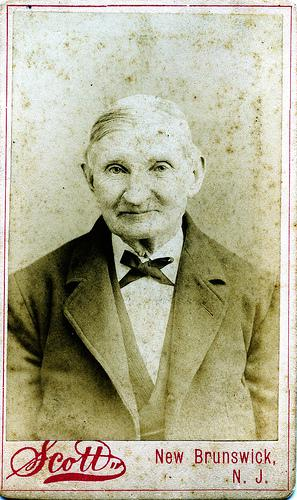Question: where was this picture taken?
Choices:
A. Las Vegas, NV.
B. New Brunswick, NJ.
C. Houston,TX.
D. Atlanta, GA.
Answer with the letter. Answer: B Question: where is the tie?
Choices:
A. In the closet.
B. Around the man's neck.
C. In the dresser drawer.
D. In the man's pocket.
Answer with the letter. Answer: B Question: what name is on the picture?
Choices:
A. Fred.
B. Jeff.
C. Scott.
D. Pete.
Answer with the letter. Answer: C Question: what color are the letters?
Choices:
A. Black.
B. Red.
C. White.
D. Green.
Answer with the letter. Answer: B Question: what kind of photo is this?
Choices:
A. Black and white.
B. Color.
C. Enlarged.
D. Sepia.
Answer with the letter. Answer: A Question: what kind of coat is the man wearing?
Choices:
A. Suit coat.
B. Jacket.
C. A rain coat.
D. Trench.
Answer with the letter. Answer: A 